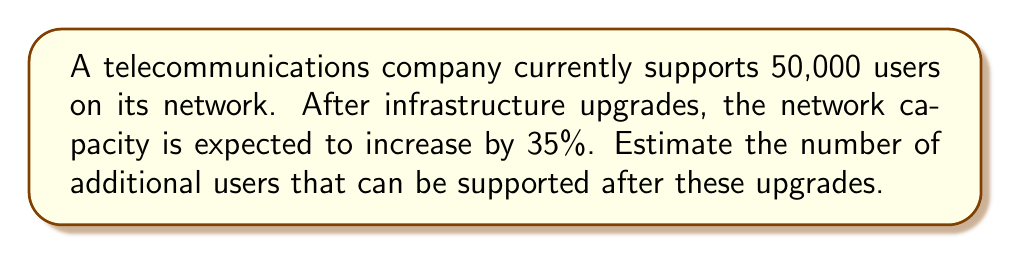What is the answer to this math problem? To solve this problem, we'll follow these steps:

1. Calculate the increase in network capacity:
   Current capacity = 100%
   Increase = 35%
   New capacity = 100% + 35% = 135%

2. Express the new capacity as a decimal:
   135% = 1.35

3. Calculate the new number of users:
   New users = Current users × New capacity
   New users = 50,000 × 1.35 = 67,500

4. Calculate the additional users:
   Additional users = New users - Current users
   Additional users = 67,500 - 50,000 = 17,500

Therefore, the estimated number of additional users that can be supported after the infrastructure upgrades is 17,500.
Answer: 17,500 additional users 